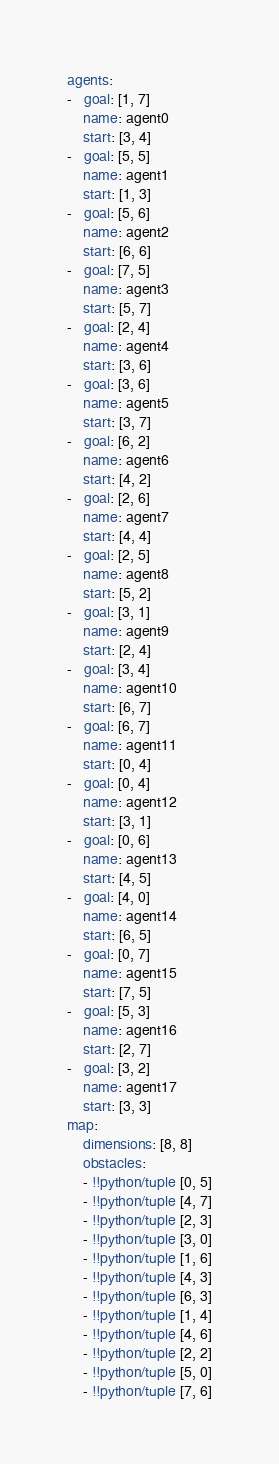<code> <loc_0><loc_0><loc_500><loc_500><_YAML_>agents:
-   goal: [1, 7]
    name: agent0
    start: [3, 4]
-   goal: [5, 5]
    name: agent1
    start: [1, 3]
-   goal: [5, 6]
    name: agent2
    start: [6, 6]
-   goal: [7, 5]
    name: agent3
    start: [5, 7]
-   goal: [2, 4]
    name: agent4
    start: [3, 6]
-   goal: [3, 6]
    name: agent5
    start: [3, 7]
-   goal: [6, 2]
    name: agent6
    start: [4, 2]
-   goal: [2, 6]
    name: agent7
    start: [4, 4]
-   goal: [2, 5]
    name: agent8
    start: [5, 2]
-   goal: [3, 1]
    name: agent9
    start: [2, 4]
-   goal: [3, 4]
    name: agent10
    start: [6, 7]
-   goal: [6, 7]
    name: agent11
    start: [0, 4]
-   goal: [0, 4]
    name: agent12
    start: [3, 1]
-   goal: [0, 6]
    name: agent13
    start: [4, 5]
-   goal: [4, 0]
    name: agent14
    start: [6, 5]
-   goal: [0, 7]
    name: agent15
    start: [7, 5]
-   goal: [5, 3]
    name: agent16
    start: [2, 7]
-   goal: [3, 2]
    name: agent17
    start: [3, 3]
map:
    dimensions: [8, 8]
    obstacles:
    - !!python/tuple [0, 5]
    - !!python/tuple [4, 7]
    - !!python/tuple [2, 3]
    - !!python/tuple [3, 0]
    - !!python/tuple [1, 6]
    - !!python/tuple [4, 3]
    - !!python/tuple [6, 3]
    - !!python/tuple [1, 4]
    - !!python/tuple [4, 6]
    - !!python/tuple [2, 2]
    - !!python/tuple [5, 0]
    - !!python/tuple [7, 6]
</code> 